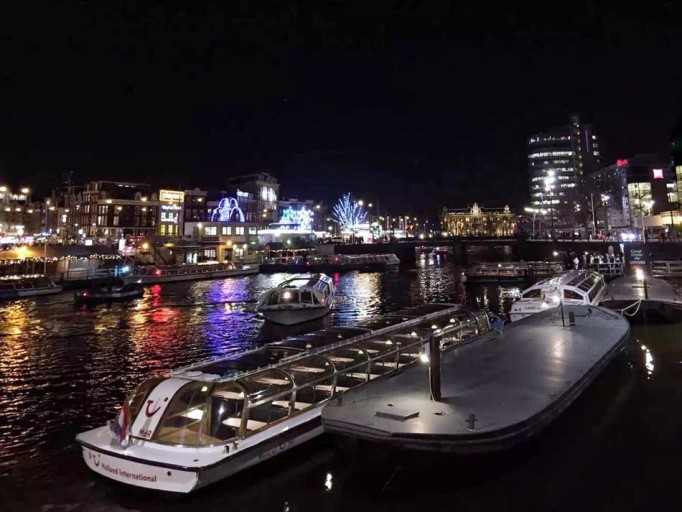What time of day does this image appear to depict? The image captures a night scene, as evidenced by the artificial lighting and reflections on the water, which create a serene and picturesque atmosphere. 